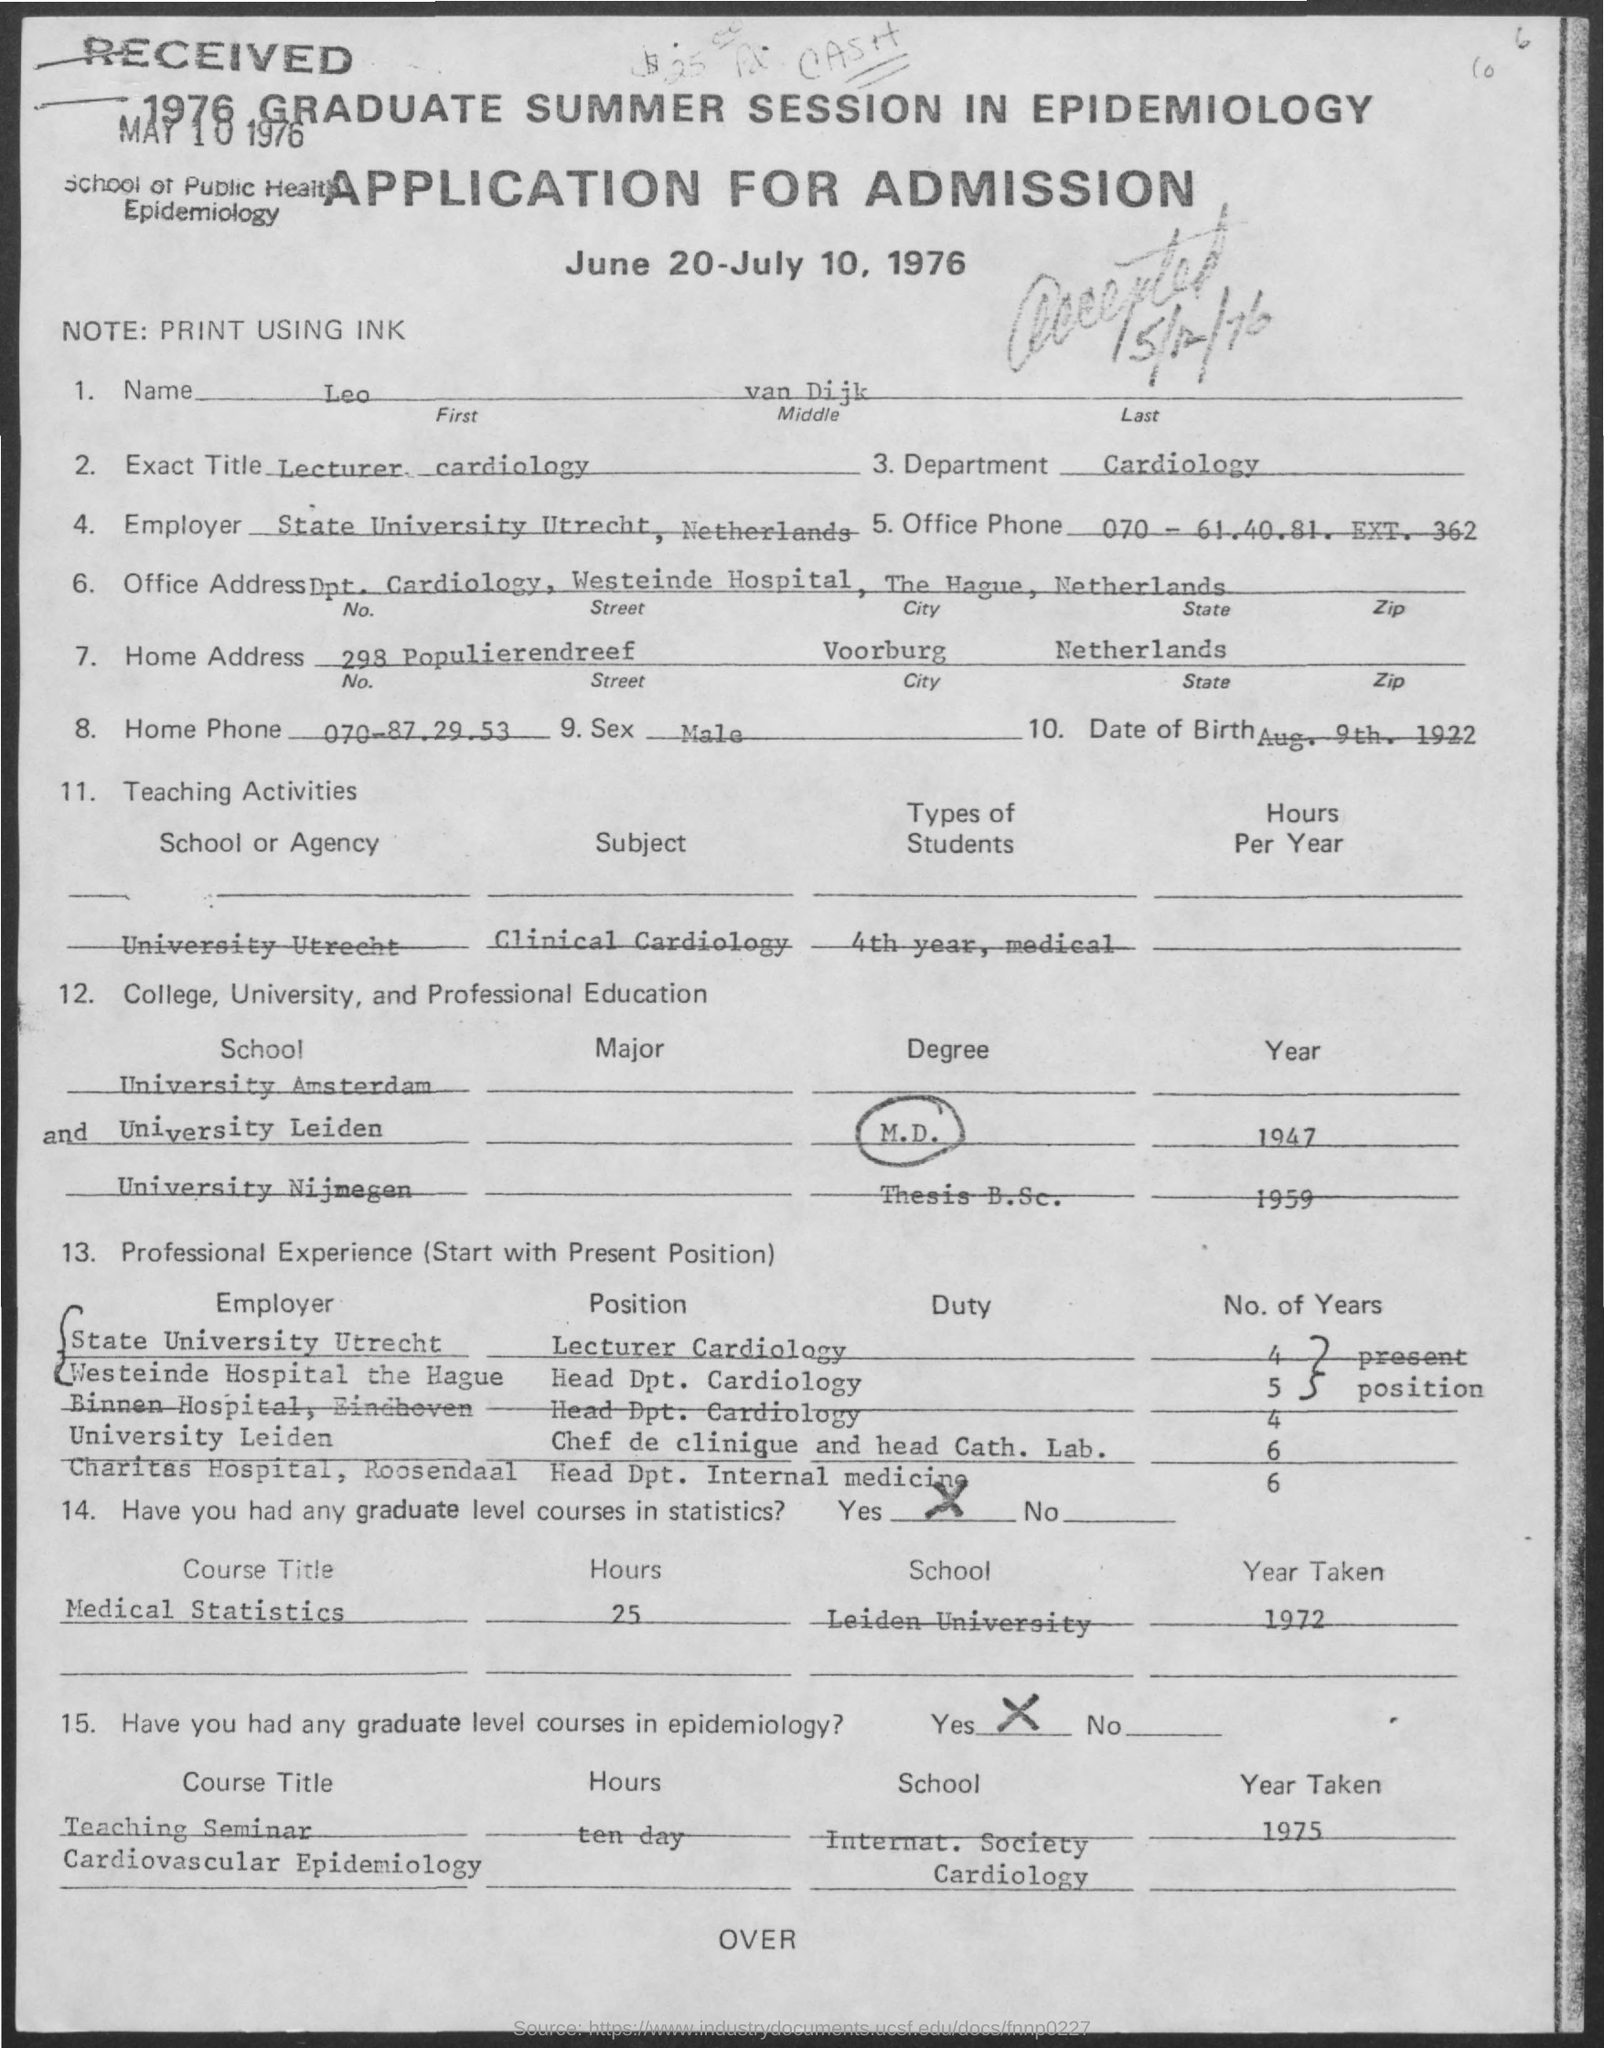Indicate a few pertinent items in this graphic. The department mentioned in the given application is cardiology. The home address contains the name of a state that is Netherlands. The home phone number provided in the application is 070-87.29.53.. The date of birth mentioned in the given application is August 9th, 1922. The sex mentioned in the given application is male. 